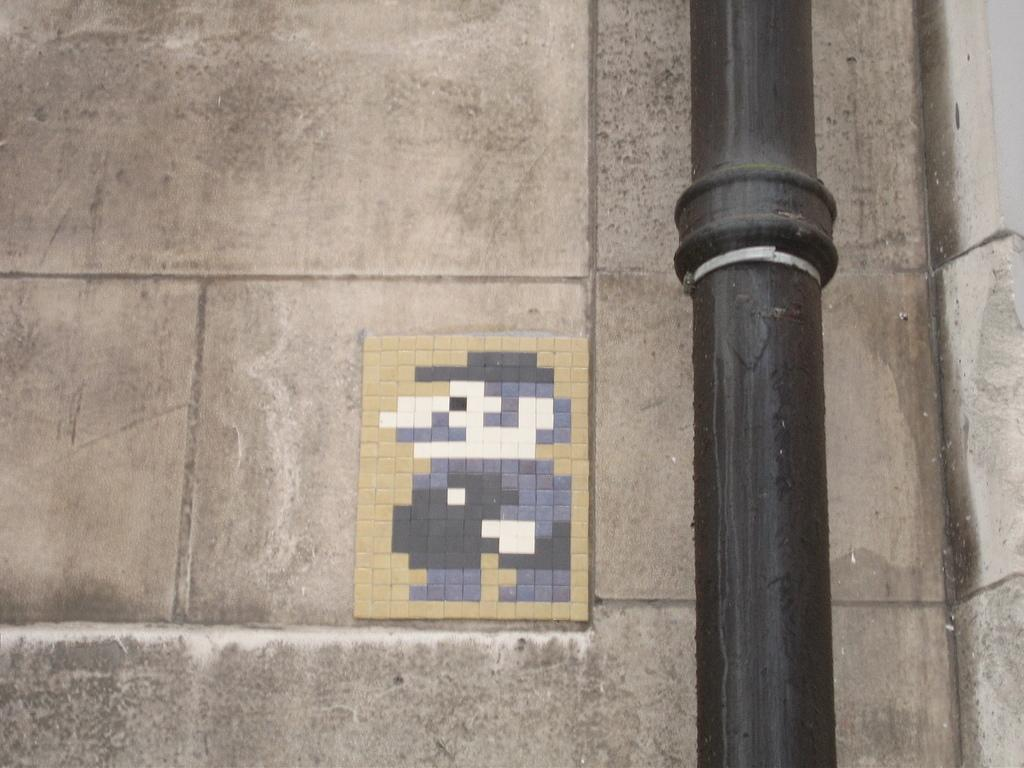What object can be seen on the right side of the image? There is a black color pole on the right side of the image. What is located in the middle of the image? There is a puzzle board in the middle of the image. What can be seen in the background of the image? There is a wall visible in the background of the image. What type of pie is being served on the puzzle board in the image? There is no pie present in the image; it features a puzzle board and a black color pole. What kind of pump is visible on the wall in the background of the image? There is no pump visible on the wall in the background of the image; it only shows a wall. 